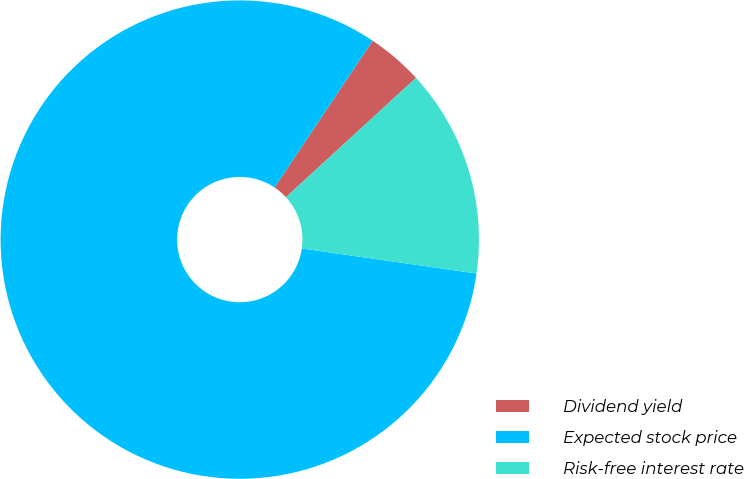<chart> <loc_0><loc_0><loc_500><loc_500><pie_chart><fcel>Dividend yield<fcel>Expected stock price<fcel>Risk-free interest rate<nl><fcel>3.81%<fcel>82.11%<fcel>14.08%<nl></chart> 